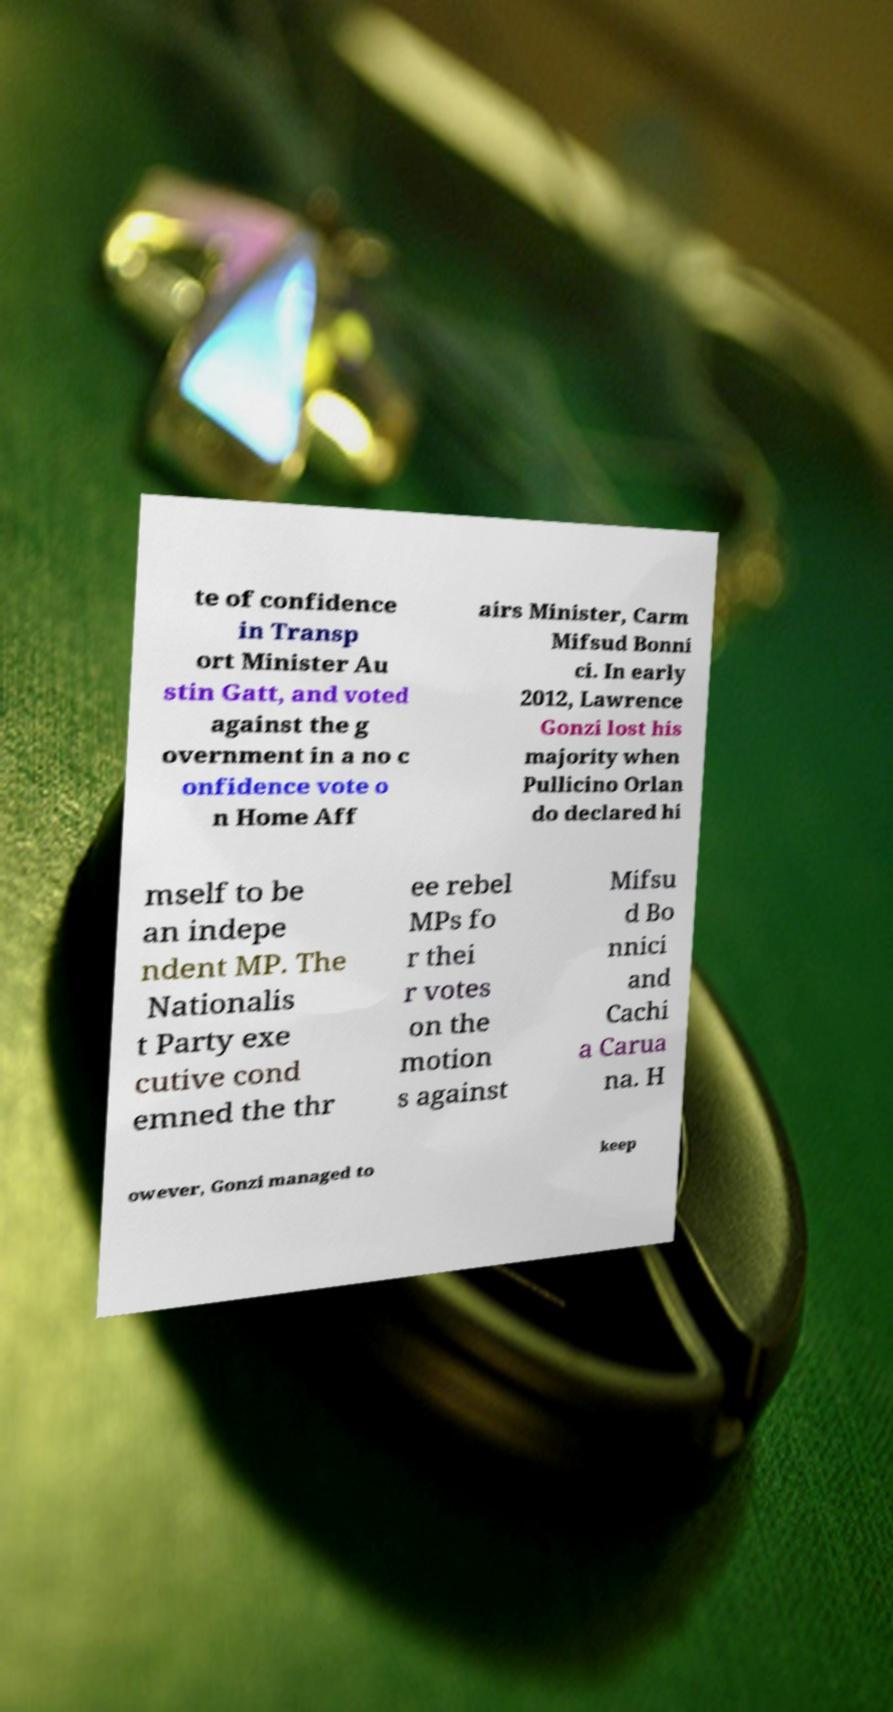Please read and relay the text visible in this image. What does it say? te of confidence in Transp ort Minister Au stin Gatt, and voted against the g overnment in a no c onfidence vote o n Home Aff airs Minister, Carm Mifsud Bonni ci. In early 2012, Lawrence Gonzi lost his majority when Pullicino Orlan do declared hi mself to be an indepe ndent MP. The Nationalis t Party exe cutive cond emned the thr ee rebel MPs fo r thei r votes on the motion s against Mifsu d Bo nnici and Cachi a Carua na. H owever, Gonzi managed to keep 